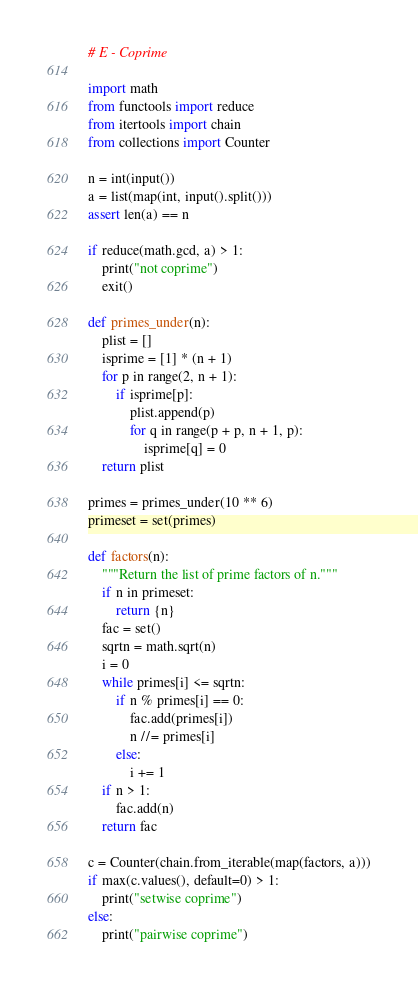Convert code to text. <code><loc_0><loc_0><loc_500><loc_500><_Python_># E - Coprime

import math
from functools import reduce
from itertools import chain
from collections import Counter

n = int(input())
a = list(map(int, input().split()))
assert len(a) == n

if reduce(math.gcd, a) > 1:
    print("not coprime")
    exit()

def primes_under(n):
    plist = []
    isprime = [1] * (n + 1)
    for p in range(2, n + 1):
        if isprime[p]:
            plist.append(p)
            for q in range(p + p, n + 1, p):
                isprime[q] = 0
    return plist

primes = primes_under(10 ** 6)
primeset = set(primes)

def factors(n):
    """Return the list of prime factors of n."""
    if n in primeset:
        return {n}
    fac = set()
    sqrtn = math.sqrt(n)
    i = 0
    while primes[i] <= sqrtn:
        if n % primes[i] == 0:
            fac.add(primes[i])
            n //= primes[i]
        else:
            i += 1
    if n > 1:
        fac.add(n)
    return fac

c = Counter(chain.from_iterable(map(factors, a)))
if max(c.values(), default=0) > 1:
    print("setwise coprime")
else:
    print("pairwise coprime")
</code> 